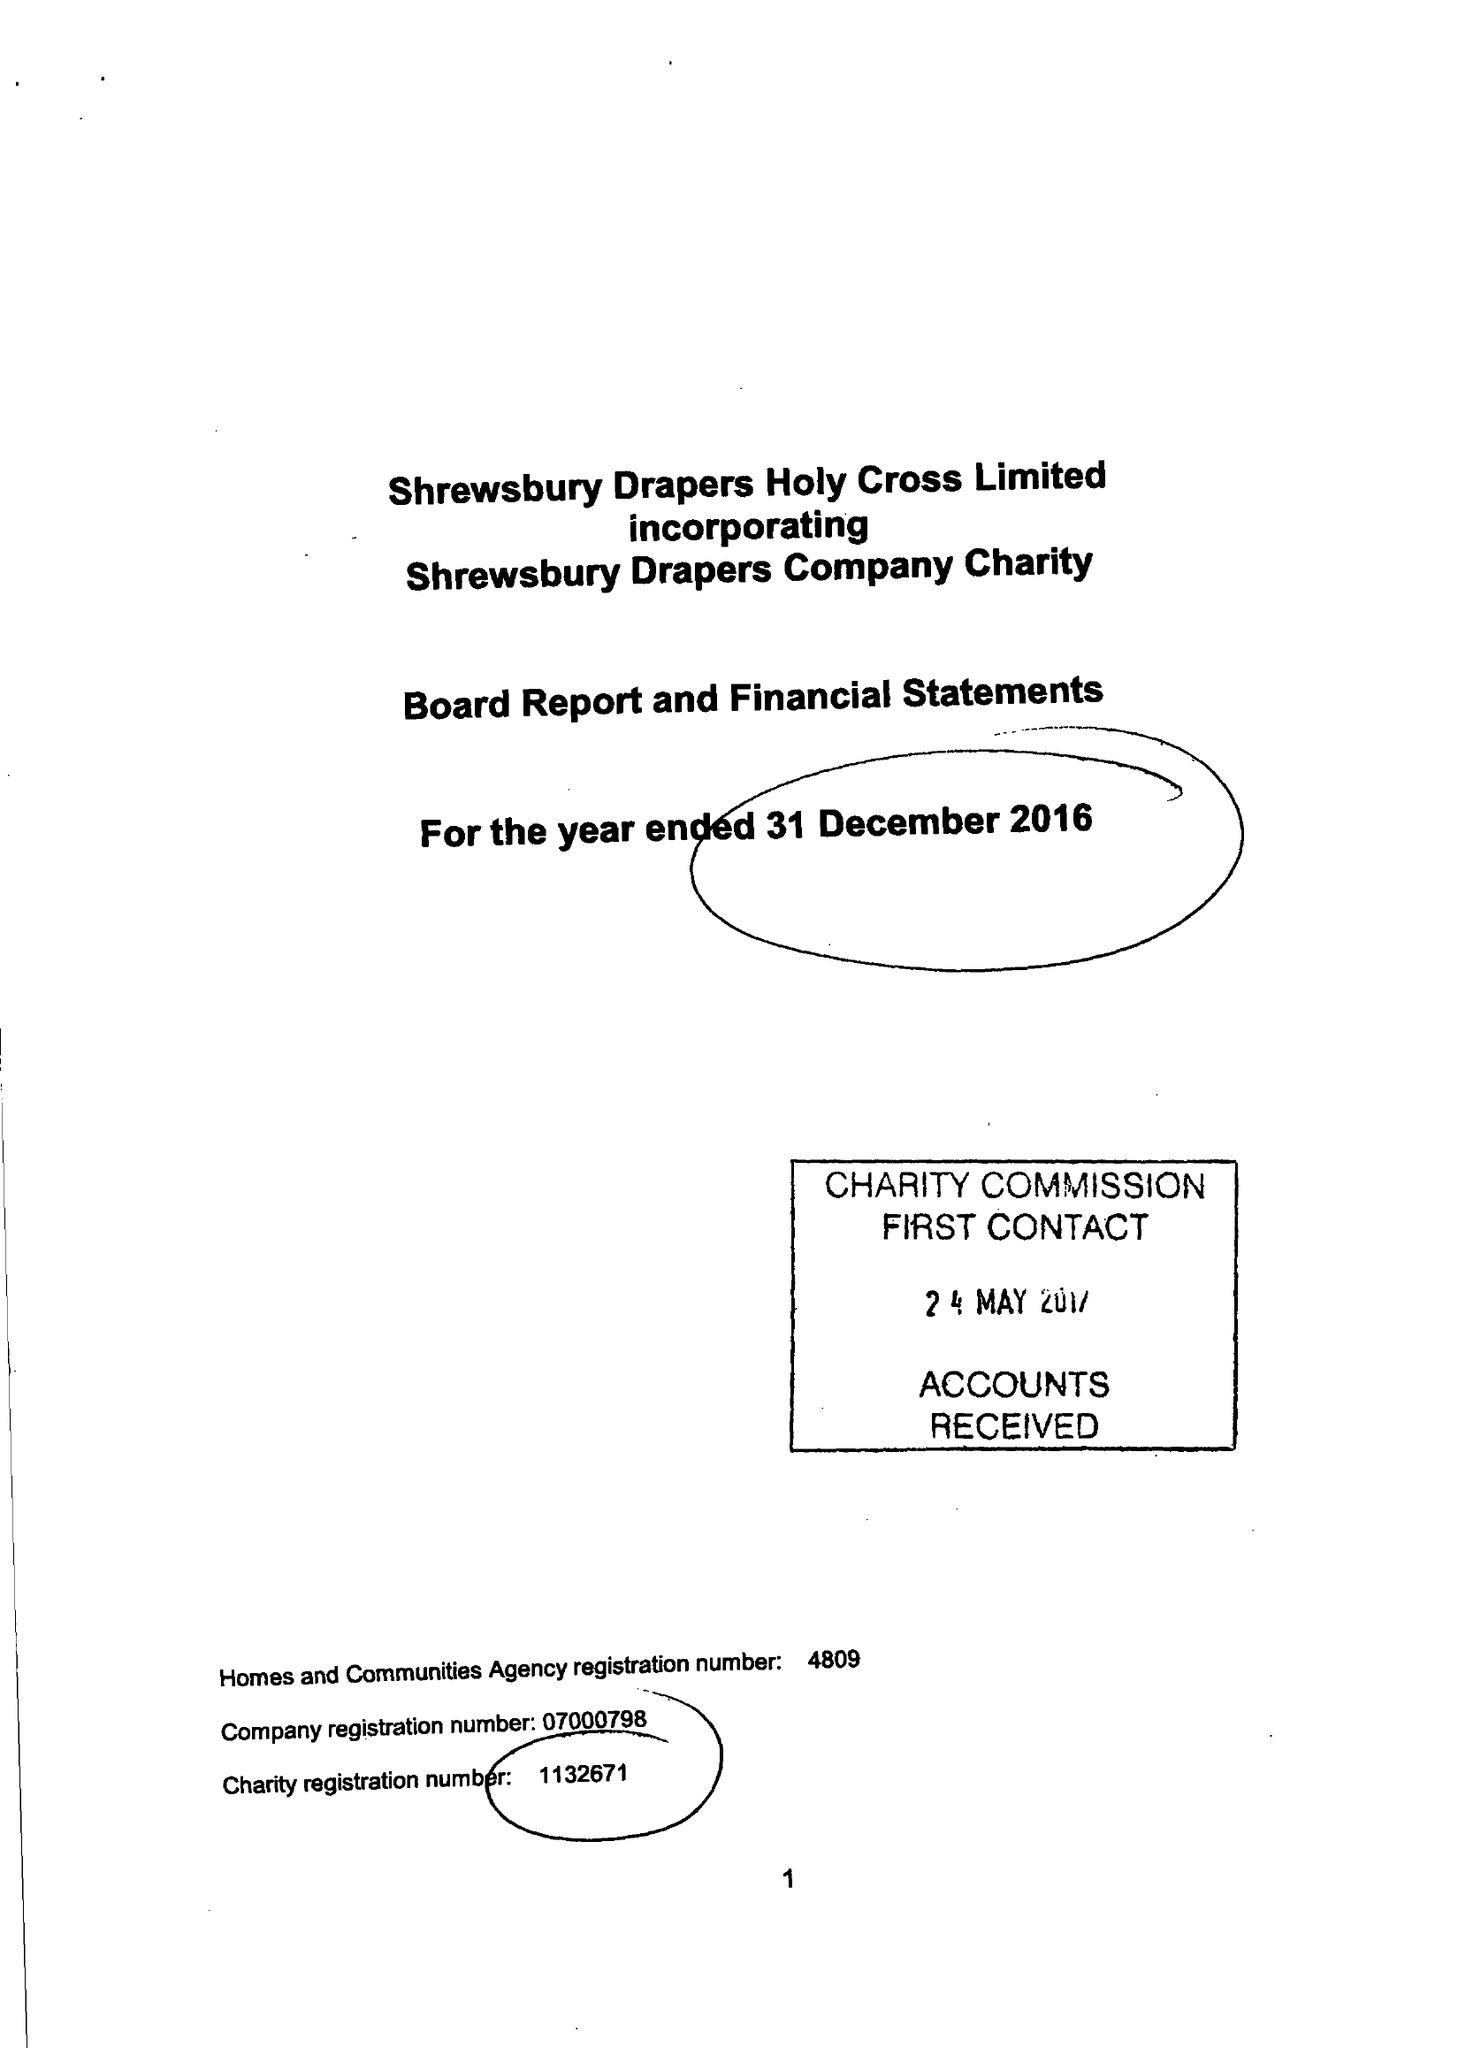What is the value for the address__post_town?
Answer the question using a single word or phrase. SHREWSBURY 